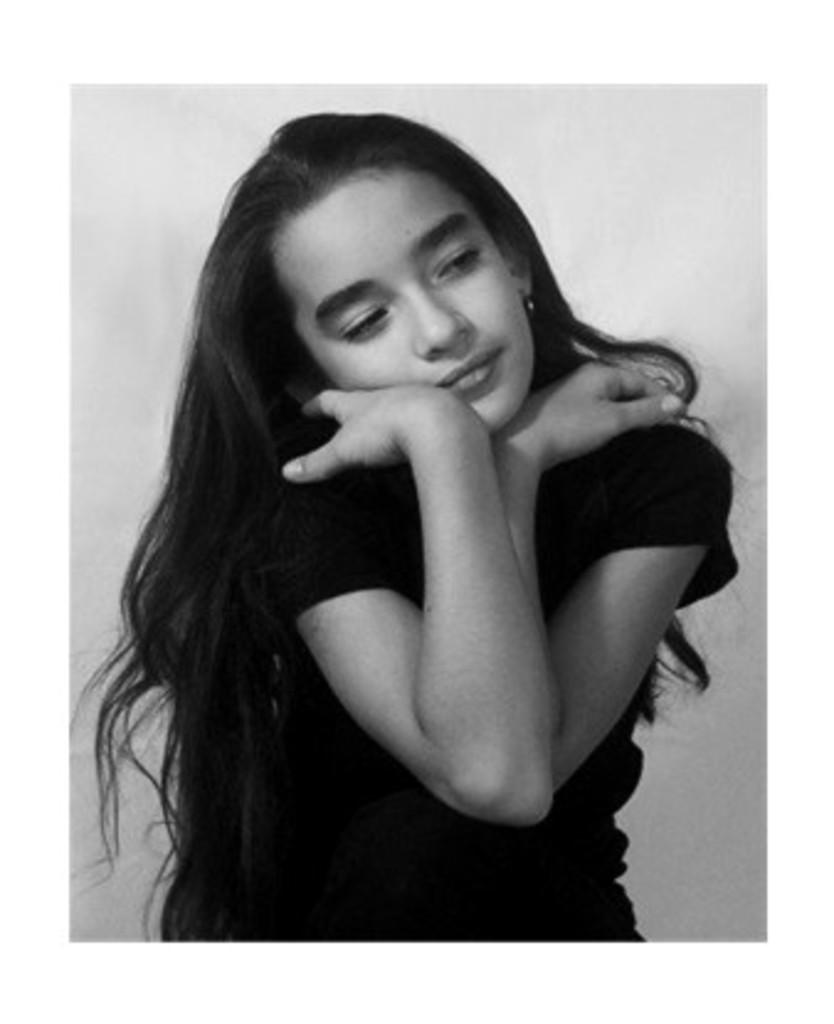What is the color scheme of the image? The image is black and white. Who is the main subject in the image? There is a girl in the middle of the image. What is the girl wearing? The girl is wearing a black t-shirt. What color is the background behind the girl? The background behind the girl is white in color. What type of pets can be seen in the image? There are no pets visible in the image; it features a girl wearing a black t-shirt against a white background. What kind of wax is used to create the girl's t-shirt in the image? The image is black and white, and there is no indication of the materials used to create the girl's t-shirt. 